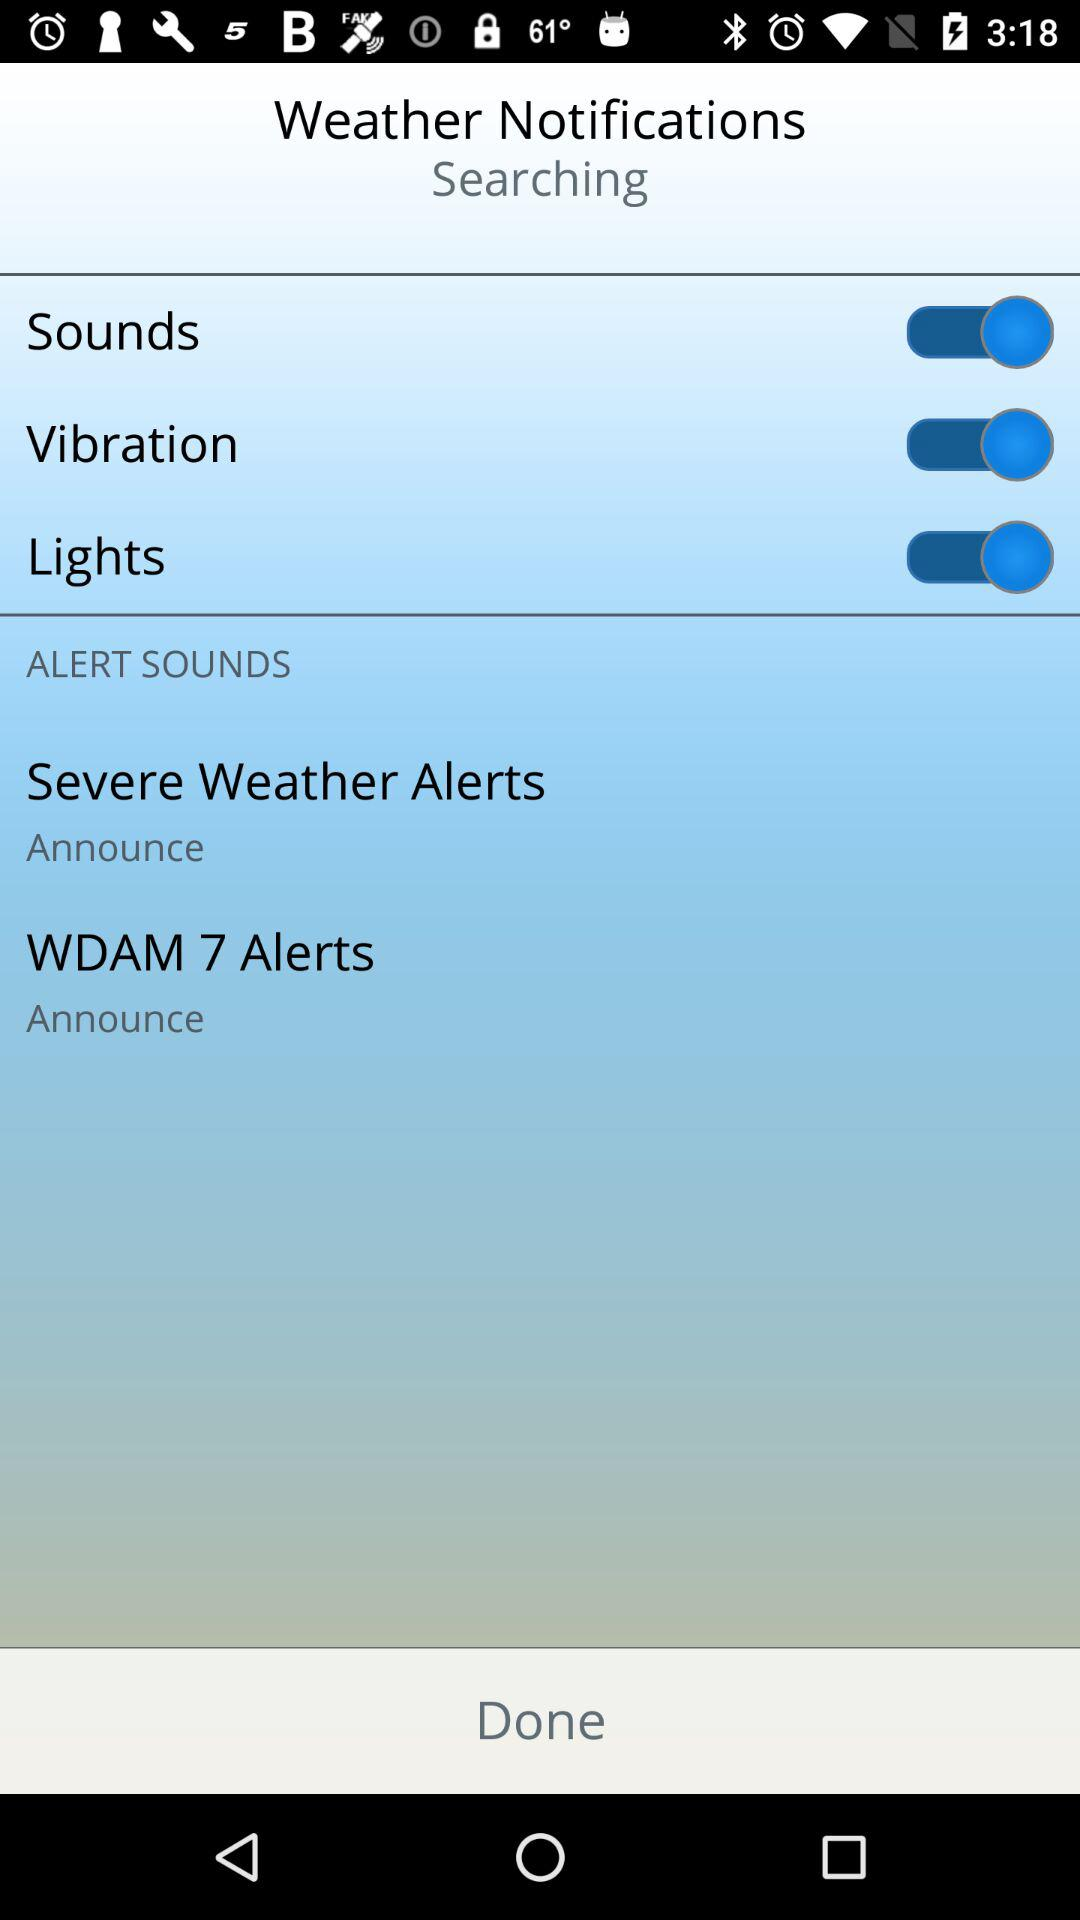What are the options that are enabled? The enabled options are "Sounds", "Vibration" and "Lights". 